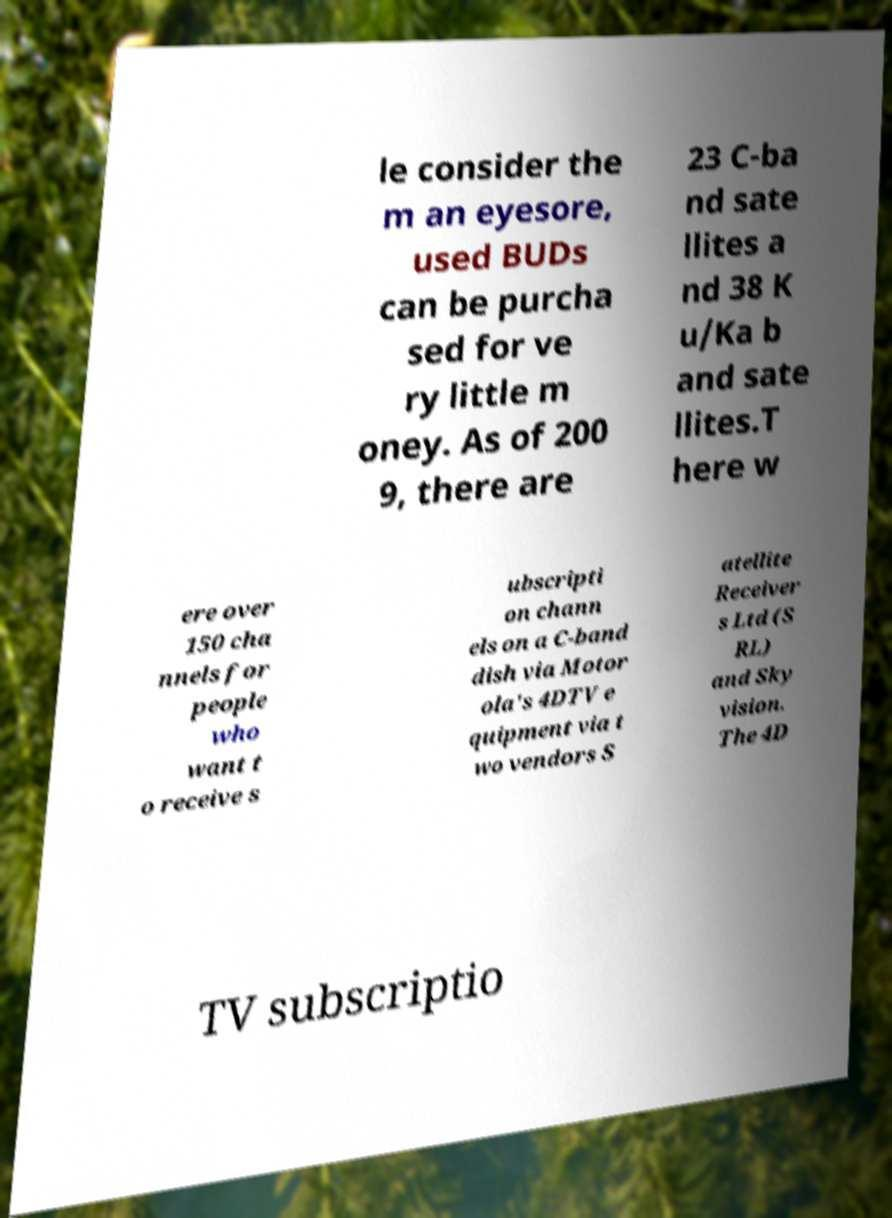For documentation purposes, I need the text within this image transcribed. Could you provide that? le consider the m an eyesore, used BUDs can be purcha sed for ve ry little m oney. As of 200 9, there are 23 C-ba nd sate llites a nd 38 K u/Ka b and sate llites.T here w ere over 150 cha nnels for people who want t o receive s ubscripti on chann els on a C-band dish via Motor ola's 4DTV e quipment via t wo vendors S atellite Receiver s Ltd (S RL) and Sky vision. The 4D TV subscriptio 